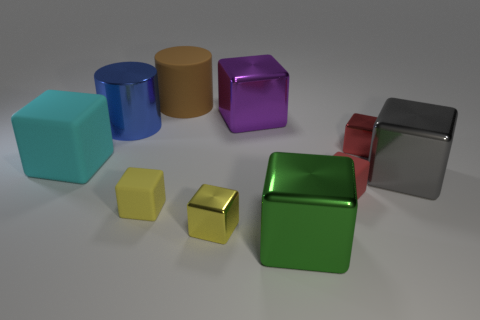Subtract 2 blocks. How many blocks are left? 6 Subtract all green blocks. How many blocks are left? 7 Subtract all big metallic cubes. How many cubes are left? 5 Subtract all yellow blocks. Subtract all green balls. How many blocks are left? 6 Subtract all cylinders. How many objects are left? 8 Subtract 1 purple blocks. How many objects are left? 9 Subtract all red matte objects. Subtract all tiny red shiny blocks. How many objects are left? 8 Add 9 blue things. How many blue things are left? 10 Add 4 tiny blue spheres. How many tiny blue spheres exist? 4 